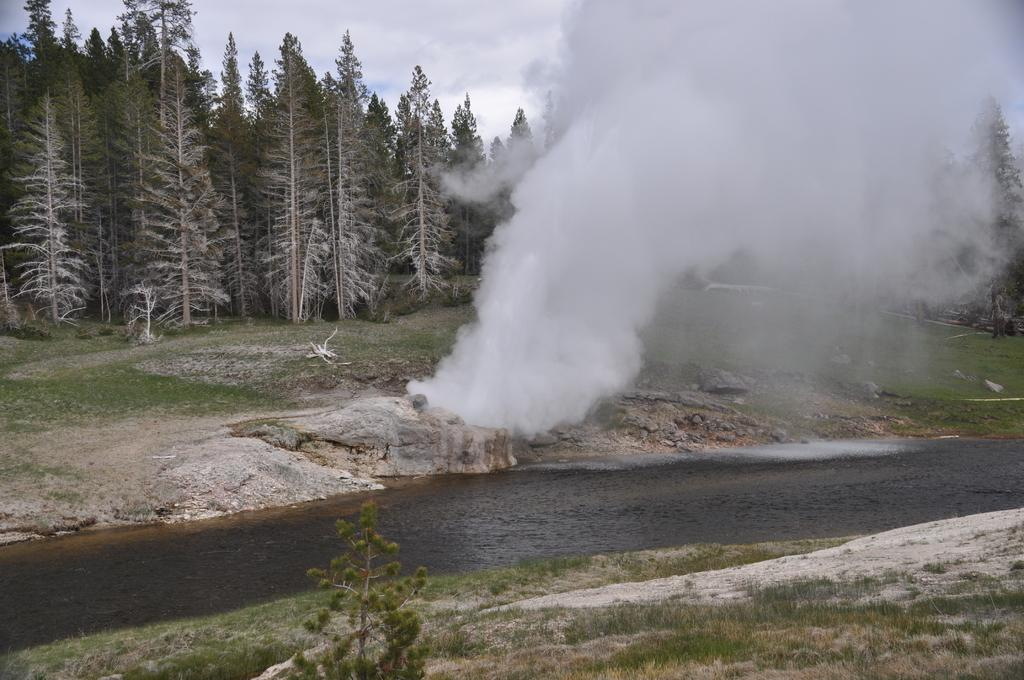What type of vegetation can be seen in the image? There is grass in the image. What natural element is also present in the image? There is water in the image. What else can be seen in the image that is not vegetation or water? There is smoke, rocks, and trees in the image. What is visible in the background of the image? The sky is visible in the background of the image. What can be seen in the sky? There are clouds in the sky. How many geese are standing on the leaf in the image? There are no geese or leaves present in the image. 